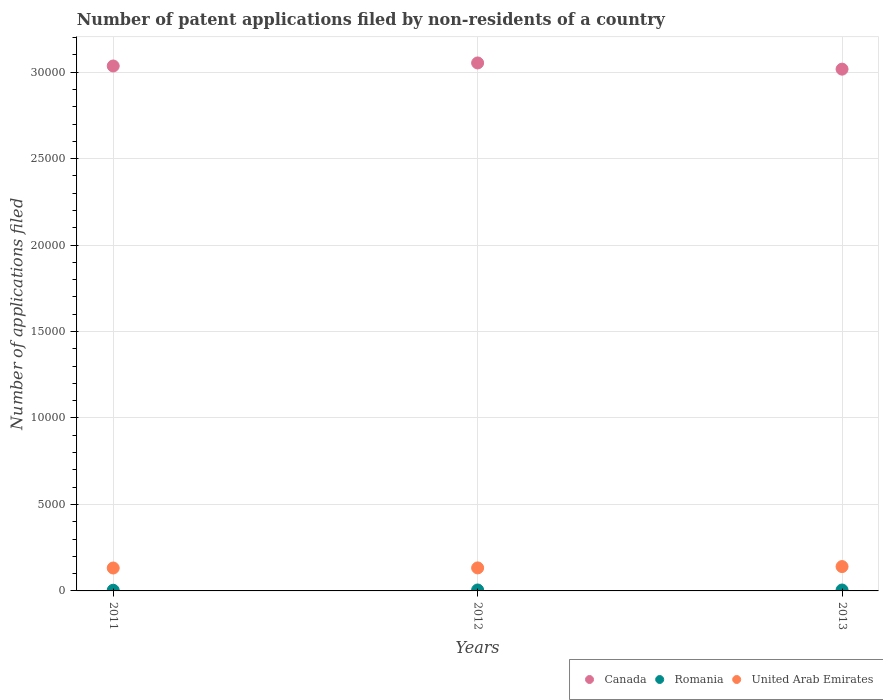Is the number of dotlines equal to the number of legend labels?
Provide a succinct answer. Yes. What is the number of applications filed in Canada in 2011?
Keep it short and to the point. 3.04e+04. Across all years, what is the maximum number of applications filed in United Arab Emirates?
Your answer should be compact. 1408. Across all years, what is the minimum number of applications filed in Romania?
Your answer should be compact. 39. In which year was the number of applications filed in Romania maximum?
Your answer should be compact. 2012. In which year was the number of applications filed in Canada minimum?
Give a very brief answer. 2013. What is the total number of applications filed in Canada in the graph?
Make the answer very short. 9.11e+04. What is the difference between the number of applications filed in Romania in 2011 and the number of applications filed in Canada in 2013?
Offer a very short reply. -3.01e+04. What is the average number of applications filed in Canada per year?
Your response must be concise. 3.04e+04. In the year 2012, what is the difference between the number of applications filed in Canada and number of applications filed in United Arab Emirates?
Your response must be concise. 2.92e+04. What is the ratio of the number of applications filed in Canada in 2012 to that in 2013?
Your response must be concise. 1.01. What is the difference between the highest and the second highest number of applications filed in Romania?
Your answer should be very brief. 2. What is the difference between the highest and the lowest number of applications filed in Canada?
Offer a terse response. 359. In how many years, is the number of applications filed in United Arab Emirates greater than the average number of applications filed in United Arab Emirates taken over all years?
Ensure brevity in your answer.  1. Is it the case that in every year, the sum of the number of applications filed in Romania and number of applications filed in United Arab Emirates  is greater than the number of applications filed in Canada?
Your answer should be compact. No. Does the number of applications filed in Romania monotonically increase over the years?
Make the answer very short. No. How many dotlines are there?
Provide a short and direct response. 3. How many years are there in the graph?
Keep it short and to the point. 3. Are the values on the major ticks of Y-axis written in scientific E-notation?
Keep it short and to the point. No. Does the graph contain any zero values?
Your response must be concise. No. How are the legend labels stacked?
Offer a very short reply. Horizontal. What is the title of the graph?
Provide a short and direct response. Number of patent applications filed by non-residents of a country. Does "Bangladesh" appear as one of the legend labels in the graph?
Keep it short and to the point. No. What is the label or title of the Y-axis?
Your response must be concise. Number of applications filed. What is the Number of applications filed of Canada in 2011?
Keep it short and to the point. 3.04e+04. What is the Number of applications filed of Romania in 2011?
Your answer should be very brief. 39. What is the Number of applications filed in United Arab Emirates in 2011?
Your answer should be very brief. 1325. What is the Number of applications filed of Canada in 2012?
Offer a very short reply. 3.05e+04. What is the Number of applications filed in Romania in 2012?
Your response must be concise. 55. What is the Number of applications filed of United Arab Emirates in 2012?
Your answer should be compact. 1331. What is the Number of applications filed in Canada in 2013?
Provide a short and direct response. 3.02e+04. What is the Number of applications filed of United Arab Emirates in 2013?
Give a very brief answer. 1408. Across all years, what is the maximum Number of applications filed in Canada?
Your answer should be very brief. 3.05e+04. Across all years, what is the maximum Number of applications filed of United Arab Emirates?
Ensure brevity in your answer.  1408. Across all years, what is the minimum Number of applications filed of Canada?
Provide a short and direct response. 3.02e+04. Across all years, what is the minimum Number of applications filed of Romania?
Make the answer very short. 39. Across all years, what is the minimum Number of applications filed in United Arab Emirates?
Make the answer very short. 1325. What is the total Number of applications filed in Canada in the graph?
Your answer should be very brief. 9.11e+04. What is the total Number of applications filed in Romania in the graph?
Provide a succinct answer. 147. What is the total Number of applications filed in United Arab Emirates in the graph?
Give a very brief answer. 4064. What is the difference between the Number of applications filed of Canada in 2011 and that in 2012?
Keep it short and to the point. -176. What is the difference between the Number of applications filed in Canada in 2011 and that in 2013?
Keep it short and to the point. 183. What is the difference between the Number of applications filed of United Arab Emirates in 2011 and that in 2013?
Your answer should be compact. -83. What is the difference between the Number of applications filed in Canada in 2012 and that in 2013?
Keep it short and to the point. 359. What is the difference between the Number of applications filed in United Arab Emirates in 2012 and that in 2013?
Keep it short and to the point. -77. What is the difference between the Number of applications filed in Canada in 2011 and the Number of applications filed in Romania in 2012?
Give a very brief answer. 3.03e+04. What is the difference between the Number of applications filed of Canada in 2011 and the Number of applications filed of United Arab Emirates in 2012?
Keep it short and to the point. 2.90e+04. What is the difference between the Number of applications filed of Romania in 2011 and the Number of applications filed of United Arab Emirates in 2012?
Offer a very short reply. -1292. What is the difference between the Number of applications filed in Canada in 2011 and the Number of applications filed in Romania in 2013?
Your answer should be very brief. 3.03e+04. What is the difference between the Number of applications filed in Canada in 2011 and the Number of applications filed in United Arab Emirates in 2013?
Provide a succinct answer. 2.89e+04. What is the difference between the Number of applications filed in Romania in 2011 and the Number of applications filed in United Arab Emirates in 2013?
Your response must be concise. -1369. What is the difference between the Number of applications filed in Canada in 2012 and the Number of applications filed in Romania in 2013?
Your answer should be compact. 3.05e+04. What is the difference between the Number of applications filed in Canada in 2012 and the Number of applications filed in United Arab Emirates in 2013?
Make the answer very short. 2.91e+04. What is the difference between the Number of applications filed of Romania in 2012 and the Number of applications filed of United Arab Emirates in 2013?
Offer a terse response. -1353. What is the average Number of applications filed in Canada per year?
Give a very brief answer. 3.04e+04. What is the average Number of applications filed of United Arab Emirates per year?
Provide a succinct answer. 1354.67. In the year 2011, what is the difference between the Number of applications filed in Canada and Number of applications filed in Romania?
Keep it short and to the point. 3.03e+04. In the year 2011, what is the difference between the Number of applications filed of Canada and Number of applications filed of United Arab Emirates?
Your response must be concise. 2.90e+04. In the year 2011, what is the difference between the Number of applications filed in Romania and Number of applications filed in United Arab Emirates?
Make the answer very short. -1286. In the year 2012, what is the difference between the Number of applications filed of Canada and Number of applications filed of Romania?
Provide a short and direct response. 3.05e+04. In the year 2012, what is the difference between the Number of applications filed of Canada and Number of applications filed of United Arab Emirates?
Make the answer very short. 2.92e+04. In the year 2012, what is the difference between the Number of applications filed in Romania and Number of applications filed in United Arab Emirates?
Make the answer very short. -1276. In the year 2013, what is the difference between the Number of applications filed of Canada and Number of applications filed of Romania?
Provide a short and direct response. 3.01e+04. In the year 2013, what is the difference between the Number of applications filed of Canada and Number of applications filed of United Arab Emirates?
Offer a very short reply. 2.88e+04. In the year 2013, what is the difference between the Number of applications filed in Romania and Number of applications filed in United Arab Emirates?
Offer a very short reply. -1355. What is the ratio of the Number of applications filed in Romania in 2011 to that in 2012?
Your answer should be compact. 0.71. What is the ratio of the Number of applications filed of Romania in 2011 to that in 2013?
Offer a terse response. 0.74. What is the ratio of the Number of applications filed in United Arab Emirates in 2011 to that in 2013?
Give a very brief answer. 0.94. What is the ratio of the Number of applications filed in Canada in 2012 to that in 2013?
Make the answer very short. 1.01. What is the ratio of the Number of applications filed in Romania in 2012 to that in 2013?
Your answer should be very brief. 1.04. What is the ratio of the Number of applications filed in United Arab Emirates in 2012 to that in 2013?
Give a very brief answer. 0.95. What is the difference between the highest and the second highest Number of applications filed in Canada?
Your answer should be very brief. 176. What is the difference between the highest and the second highest Number of applications filed in Romania?
Your answer should be compact. 2. What is the difference between the highest and the lowest Number of applications filed of Canada?
Your answer should be very brief. 359. What is the difference between the highest and the lowest Number of applications filed of United Arab Emirates?
Your answer should be very brief. 83. 